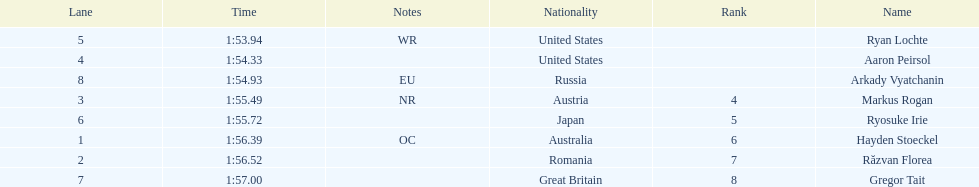How many swimmers finished in less than 1:55? 3. 